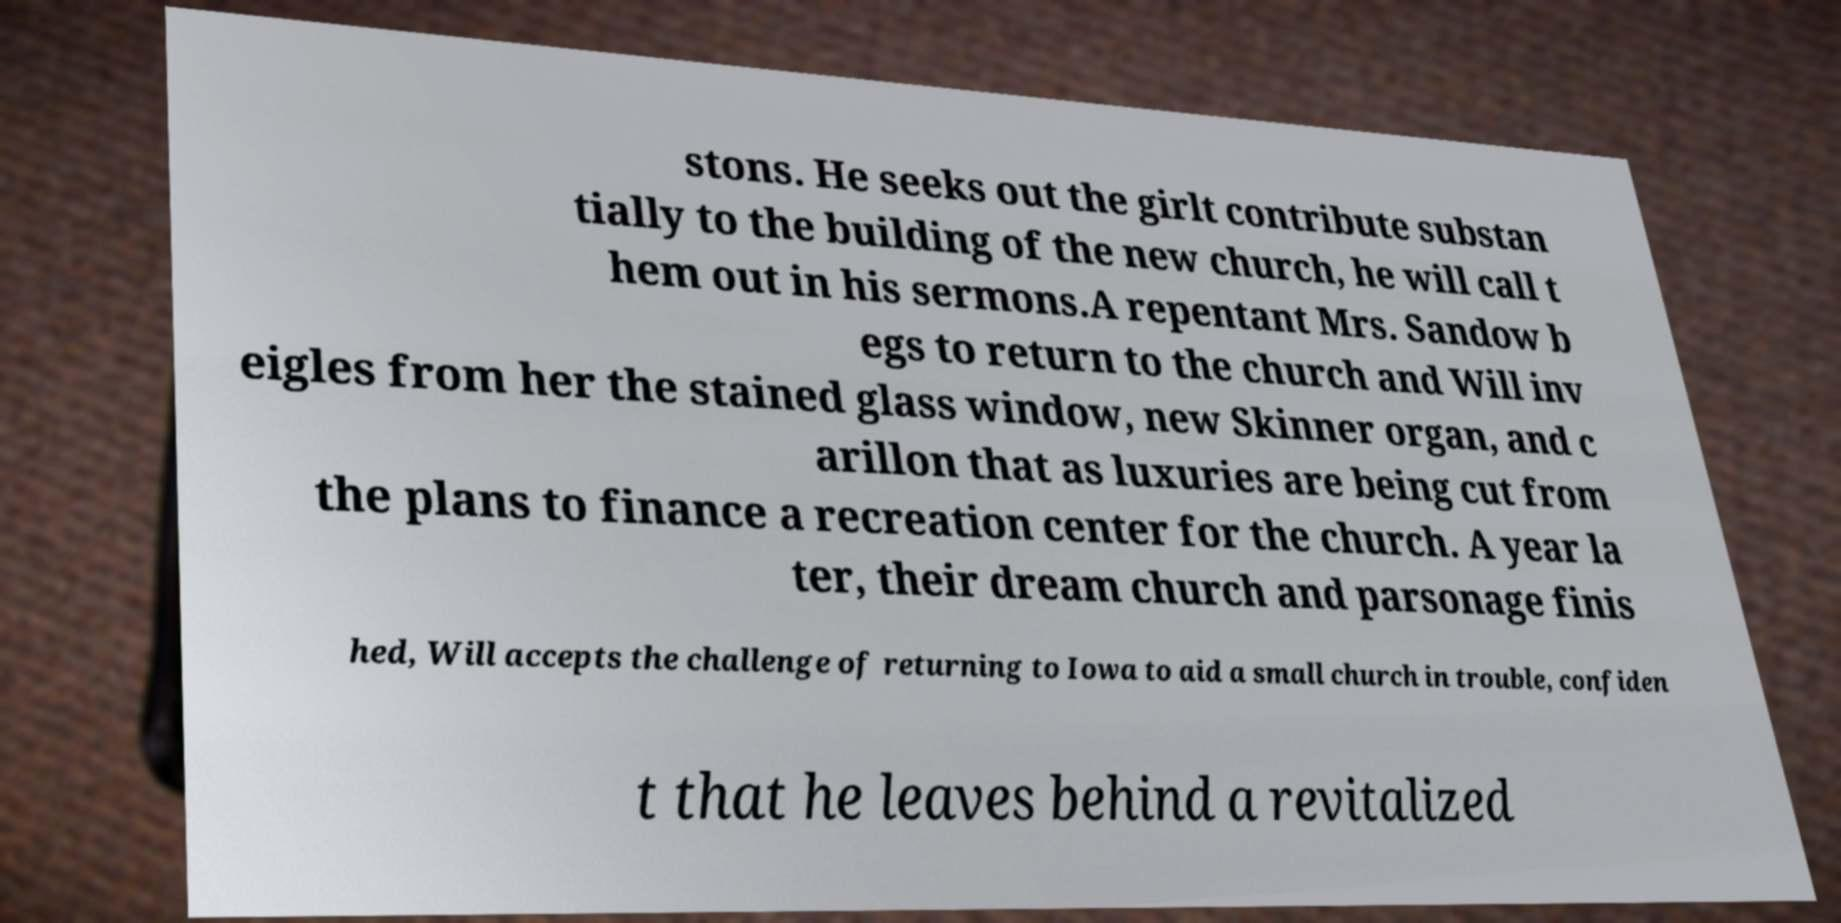Could you assist in decoding the text presented in this image and type it out clearly? stons. He seeks out the girlt contribute substan tially to the building of the new church, he will call t hem out in his sermons.A repentant Mrs. Sandow b egs to return to the church and Will inv eigles from her the stained glass window, new Skinner organ, and c arillon that as luxuries are being cut from the plans to finance a recreation center for the church. A year la ter, their dream church and parsonage finis hed, Will accepts the challenge of returning to Iowa to aid a small church in trouble, confiden t that he leaves behind a revitalized 